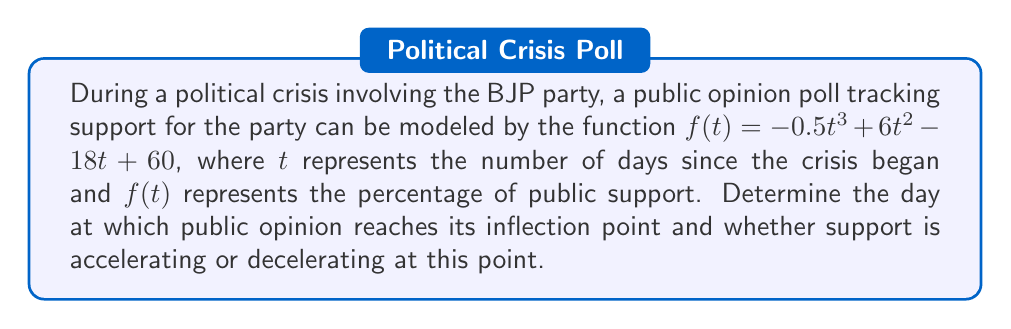Give your solution to this math problem. To find the inflection point, we need to follow these steps:

1) First, we calculate the first derivative of $f(t)$:
   $$f'(t) = -1.5t^2 + 12t - 18$$

2) Then, we calculate the second derivative:
   $$f''(t) = -3t + 12$$

3) The inflection point occurs where the second derivative equals zero:
   $$f''(t) = 0$$
   $$-3t + 12 = 0$$
   $$-3t = -12$$
   $$t = 4$$

4) To determine if support is accelerating or decelerating at this point, we need to examine the sign of $f''(t)$ before and after $t = 4$:

   For $t < 4$, $f''(t) > 0$
   For $t > 4$, $f''(t) < 0$

   This indicates that the curve changes from concave up to concave down at $t = 4$, meaning support is decelerating at the inflection point.

5) To verify this is indeed a point of inflection, we can check that $f'(t)$ has a local extreme at $t = 4$:
   
   $$f'(4) = -1.5(4)^2 + 12(4) - 18 = -24 + 48 - 18 = 6$$

   This confirms that $t = 4$ is indeed an inflection point.
Answer: The inflection point occurs on day 4, and support is decelerating at this point. 